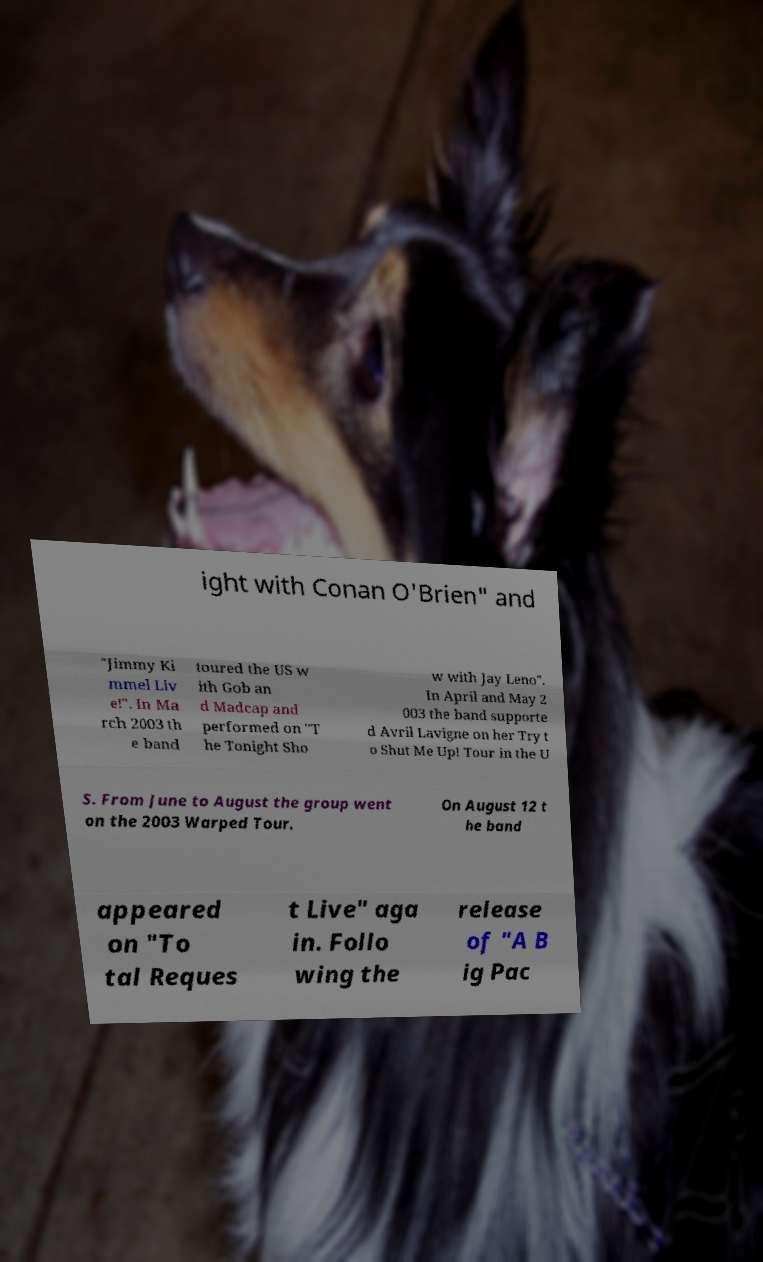I need the written content from this picture converted into text. Can you do that? ight with Conan O'Brien" and "Jimmy Ki mmel Liv e!". In Ma rch 2003 th e band toured the US w ith Gob an d Madcap and performed on "T he Tonight Sho w with Jay Leno". In April and May 2 003 the band supporte d Avril Lavigne on her Try t o Shut Me Up! Tour in the U S. From June to August the group went on the 2003 Warped Tour. On August 12 t he band appeared on "To tal Reques t Live" aga in. Follo wing the release of "A B ig Pac 